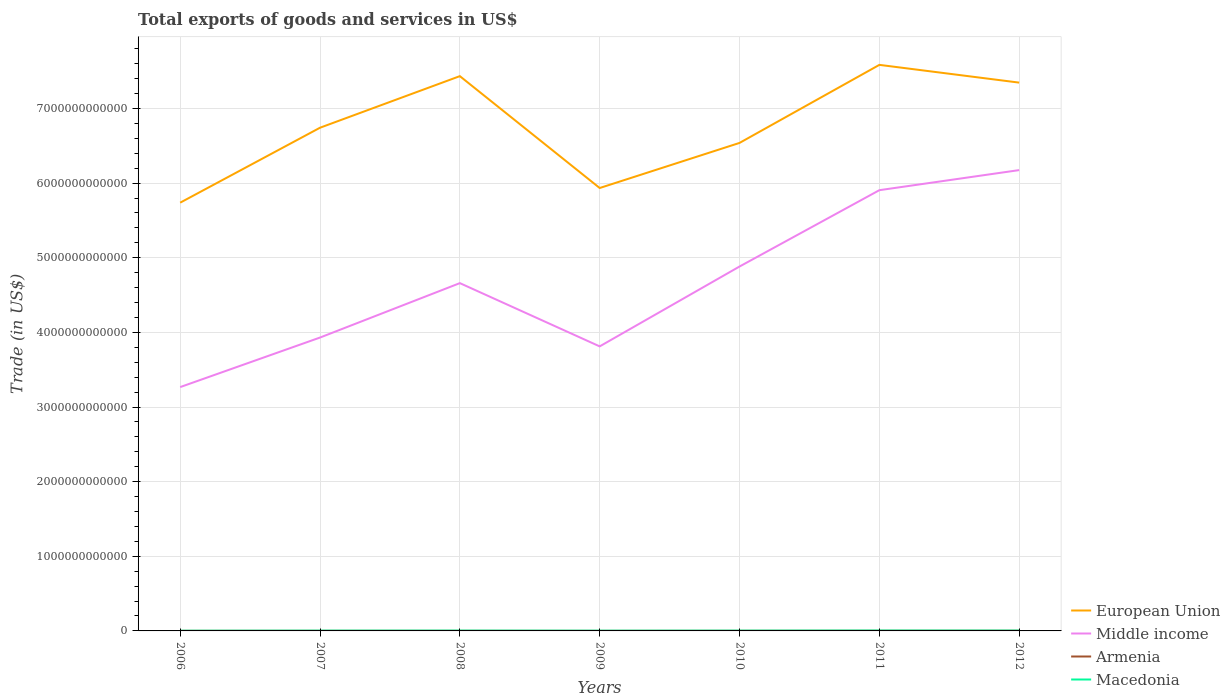How many different coloured lines are there?
Provide a short and direct response. 4. Does the line corresponding to European Union intersect with the line corresponding to Armenia?
Your answer should be compact. No. Across all years, what is the maximum total exports of goods and services in Middle income?
Give a very brief answer. 3.27e+12. In which year was the total exports of goods and services in Armenia maximum?
Provide a short and direct response. 2009. What is the total total exports of goods and services in Macedonia in the graph?
Offer a terse response. -1.34e+09. What is the difference between the highest and the second highest total exports of goods and services in Macedonia?
Make the answer very short. 2.35e+09. What is the difference between the highest and the lowest total exports of goods and services in European Union?
Your answer should be compact. 3. How many years are there in the graph?
Provide a succinct answer. 7. What is the difference between two consecutive major ticks on the Y-axis?
Make the answer very short. 1.00e+12. Are the values on the major ticks of Y-axis written in scientific E-notation?
Offer a very short reply. No. Does the graph contain any zero values?
Your answer should be very brief. No. Does the graph contain grids?
Ensure brevity in your answer.  Yes. Where does the legend appear in the graph?
Your answer should be compact. Bottom right. What is the title of the graph?
Provide a succinct answer. Total exports of goods and services in US$. Does "Dominica" appear as one of the legend labels in the graph?
Ensure brevity in your answer.  No. What is the label or title of the Y-axis?
Ensure brevity in your answer.  Trade (in US$). What is the Trade (in US$) in European Union in 2006?
Your answer should be compact. 5.74e+12. What is the Trade (in US$) of Middle income in 2006?
Give a very brief answer. 3.27e+12. What is the Trade (in US$) of Armenia in 2006?
Provide a succinct answer. 1.49e+09. What is the Trade (in US$) in Macedonia in 2006?
Make the answer very short. 2.59e+09. What is the Trade (in US$) in European Union in 2007?
Give a very brief answer. 6.74e+12. What is the Trade (in US$) in Middle income in 2007?
Offer a terse response. 3.93e+12. What is the Trade (in US$) in Armenia in 2007?
Your answer should be compact. 1.77e+09. What is the Trade (in US$) in Macedonia in 2007?
Offer a very short reply. 3.68e+09. What is the Trade (in US$) in European Union in 2008?
Provide a succinct answer. 7.43e+12. What is the Trade (in US$) of Middle income in 2008?
Give a very brief answer. 4.66e+12. What is the Trade (in US$) of Armenia in 2008?
Give a very brief answer. 1.75e+09. What is the Trade (in US$) of Macedonia in 2008?
Give a very brief answer. 4.28e+09. What is the Trade (in US$) in European Union in 2009?
Ensure brevity in your answer.  5.93e+12. What is the Trade (in US$) in Middle income in 2009?
Make the answer very short. 3.81e+12. What is the Trade (in US$) in Armenia in 2009?
Make the answer very short. 1.34e+09. What is the Trade (in US$) in Macedonia in 2009?
Give a very brief answer. 3.08e+09. What is the Trade (in US$) in European Union in 2010?
Offer a very short reply. 6.54e+12. What is the Trade (in US$) of Middle income in 2010?
Provide a succinct answer. 4.88e+12. What is the Trade (in US$) in Armenia in 2010?
Provide a succinct answer. 1.93e+09. What is the Trade (in US$) of Macedonia in 2010?
Offer a terse response. 3.74e+09. What is the Trade (in US$) in European Union in 2011?
Give a very brief answer. 7.58e+12. What is the Trade (in US$) of Middle income in 2011?
Offer a very short reply. 5.91e+12. What is the Trade (in US$) in Armenia in 2011?
Offer a very short reply. 2.41e+09. What is the Trade (in US$) of Macedonia in 2011?
Give a very brief answer. 4.95e+09. What is the Trade (in US$) in European Union in 2012?
Offer a terse response. 7.35e+12. What is the Trade (in US$) in Middle income in 2012?
Provide a short and direct response. 6.17e+12. What is the Trade (in US$) in Armenia in 2012?
Keep it short and to the point. 2.93e+09. What is the Trade (in US$) of Macedonia in 2012?
Provide a short and direct response. 4.42e+09. Across all years, what is the maximum Trade (in US$) of European Union?
Keep it short and to the point. 7.58e+12. Across all years, what is the maximum Trade (in US$) of Middle income?
Offer a terse response. 6.17e+12. Across all years, what is the maximum Trade (in US$) in Armenia?
Give a very brief answer. 2.93e+09. Across all years, what is the maximum Trade (in US$) of Macedonia?
Provide a short and direct response. 4.95e+09. Across all years, what is the minimum Trade (in US$) of European Union?
Offer a very short reply. 5.74e+12. Across all years, what is the minimum Trade (in US$) in Middle income?
Ensure brevity in your answer.  3.27e+12. Across all years, what is the minimum Trade (in US$) in Armenia?
Keep it short and to the point. 1.34e+09. Across all years, what is the minimum Trade (in US$) of Macedonia?
Offer a terse response. 2.59e+09. What is the total Trade (in US$) of European Union in the graph?
Ensure brevity in your answer.  4.73e+13. What is the total Trade (in US$) in Middle income in the graph?
Provide a short and direct response. 3.26e+13. What is the total Trade (in US$) in Armenia in the graph?
Make the answer very short. 1.36e+1. What is the total Trade (in US$) of Macedonia in the graph?
Your response must be concise. 2.67e+1. What is the difference between the Trade (in US$) of European Union in 2006 and that in 2007?
Provide a short and direct response. -1.00e+12. What is the difference between the Trade (in US$) of Middle income in 2006 and that in 2007?
Offer a very short reply. -6.64e+11. What is the difference between the Trade (in US$) of Armenia in 2006 and that in 2007?
Your answer should be very brief. -2.75e+08. What is the difference between the Trade (in US$) in Macedonia in 2006 and that in 2007?
Provide a succinct answer. -1.08e+09. What is the difference between the Trade (in US$) in European Union in 2006 and that in 2008?
Provide a succinct answer. -1.70e+12. What is the difference between the Trade (in US$) of Middle income in 2006 and that in 2008?
Give a very brief answer. -1.39e+12. What is the difference between the Trade (in US$) of Armenia in 2006 and that in 2008?
Provide a short and direct response. -2.63e+08. What is the difference between the Trade (in US$) in Macedonia in 2006 and that in 2008?
Provide a succinct answer. -1.69e+09. What is the difference between the Trade (in US$) in European Union in 2006 and that in 2009?
Offer a terse response. -1.96e+11. What is the difference between the Trade (in US$) of Middle income in 2006 and that in 2009?
Provide a succinct answer. -5.45e+11. What is the difference between the Trade (in US$) in Armenia in 2006 and that in 2009?
Your response must be concise. 1.53e+08. What is the difference between the Trade (in US$) in Macedonia in 2006 and that in 2009?
Give a very brief answer. -4.91e+08. What is the difference between the Trade (in US$) of European Union in 2006 and that in 2010?
Keep it short and to the point. -8.01e+11. What is the difference between the Trade (in US$) in Middle income in 2006 and that in 2010?
Provide a short and direct response. -1.62e+12. What is the difference between the Trade (in US$) of Armenia in 2006 and that in 2010?
Your answer should be very brief. -4.38e+08. What is the difference between the Trade (in US$) of Macedonia in 2006 and that in 2010?
Ensure brevity in your answer.  -1.15e+09. What is the difference between the Trade (in US$) of European Union in 2006 and that in 2011?
Your response must be concise. -1.85e+12. What is the difference between the Trade (in US$) in Middle income in 2006 and that in 2011?
Ensure brevity in your answer.  -2.64e+12. What is the difference between the Trade (in US$) in Armenia in 2006 and that in 2011?
Offer a terse response. -9.18e+08. What is the difference between the Trade (in US$) of Macedonia in 2006 and that in 2011?
Ensure brevity in your answer.  -2.35e+09. What is the difference between the Trade (in US$) of European Union in 2006 and that in 2012?
Your answer should be compact. -1.61e+12. What is the difference between the Trade (in US$) in Middle income in 2006 and that in 2012?
Give a very brief answer. -2.91e+12. What is the difference between the Trade (in US$) of Armenia in 2006 and that in 2012?
Keep it short and to the point. -1.44e+09. What is the difference between the Trade (in US$) in Macedonia in 2006 and that in 2012?
Give a very brief answer. -1.83e+09. What is the difference between the Trade (in US$) in European Union in 2007 and that in 2008?
Give a very brief answer. -6.91e+11. What is the difference between the Trade (in US$) in Middle income in 2007 and that in 2008?
Ensure brevity in your answer.  -7.29e+11. What is the difference between the Trade (in US$) in Armenia in 2007 and that in 2008?
Provide a succinct answer. 1.15e+07. What is the difference between the Trade (in US$) in Macedonia in 2007 and that in 2008?
Make the answer very short. -6.06e+08. What is the difference between the Trade (in US$) in European Union in 2007 and that in 2009?
Provide a succinct answer. 8.08e+11. What is the difference between the Trade (in US$) of Middle income in 2007 and that in 2009?
Offer a very short reply. 1.18e+11. What is the difference between the Trade (in US$) of Armenia in 2007 and that in 2009?
Keep it short and to the point. 4.28e+08. What is the difference between the Trade (in US$) of Macedonia in 2007 and that in 2009?
Offer a terse response. 5.94e+08. What is the difference between the Trade (in US$) of European Union in 2007 and that in 2010?
Keep it short and to the point. 2.04e+11. What is the difference between the Trade (in US$) of Middle income in 2007 and that in 2010?
Your answer should be very brief. -9.52e+11. What is the difference between the Trade (in US$) of Armenia in 2007 and that in 2010?
Provide a short and direct response. -1.63e+08. What is the difference between the Trade (in US$) in Macedonia in 2007 and that in 2010?
Your answer should be compact. -6.53e+07. What is the difference between the Trade (in US$) in European Union in 2007 and that in 2011?
Your response must be concise. -8.42e+11. What is the difference between the Trade (in US$) of Middle income in 2007 and that in 2011?
Offer a very short reply. -1.97e+12. What is the difference between the Trade (in US$) of Armenia in 2007 and that in 2011?
Ensure brevity in your answer.  -6.43e+08. What is the difference between the Trade (in US$) of Macedonia in 2007 and that in 2011?
Provide a succinct answer. -1.27e+09. What is the difference between the Trade (in US$) in European Union in 2007 and that in 2012?
Make the answer very short. -6.04e+11. What is the difference between the Trade (in US$) of Middle income in 2007 and that in 2012?
Give a very brief answer. -2.24e+12. What is the difference between the Trade (in US$) of Armenia in 2007 and that in 2012?
Your answer should be compact. -1.16e+09. What is the difference between the Trade (in US$) of Macedonia in 2007 and that in 2012?
Your response must be concise. -7.44e+08. What is the difference between the Trade (in US$) in European Union in 2008 and that in 2009?
Make the answer very short. 1.50e+12. What is the difference between the Trade (in US$) in Middle income in 2008 and that in 2009?
Your answer should be compact. 8.48e+11. What is the difference between the Trade (in US$) in Armenia in 2008 and that in 2009?
Make the answer very short. 4.17e+08. What is the difference between the Trade (in US$) in Macedonia in 2008 and that in 2009?
Provide a succinct answer. 1.20e+09. What is the difference between the Trade (in US$) in European Union in 2008 and that in 2010?
Ensure brevity in your answer.  8.95e+11. What is the difference between the Trade (in US$) of Middle income in 2008 and that in 2010?
Your response must be concise. -2.22e+11. What is the difference between the Trade (in US$) in Armenia in 2008 and that in 2010?
Make the answer very short. -1.74e+08. What is the difference between the Trade (in US$) of Macedonia in 2008 and that in 2010?
Offer a terse response. 5.40e+08. What is the difference between the Trade (in US$) of European Union in 2008 and that in 2011?
Keep it short and to the point. -1.51e+11. What is the difference between the Trade (in US$) in Middle income in 2008 and that in 2011?
Provide a succinct answer. -1.25e+12. What is the difference between the Trade (in US$) of Armenia in 2008 and that in 2011?
Give a very brief answer. -6.55e+08. What is the difference between the Trade (in US$) in Macedonia in 2008 and that in 2011?
Provide a succinct answer. -6.62e+08. What is the difference between the Trade (in US$) of European Union in 2008 and that in 2012?
Make the answer very short. 8.66e+1. What is the difference between the Trade (in US$) in Middle income in 2008 and that in 2012?
Offer a terse response. -1.51e+12. What is the difference between the Trade (in US$) of Armenia in 2008 and that in 2012?
Make the answer very short. -1.17e+09. What is the difference between the Trade (in US$) in Macedonia in 2008 and that in 2012?
Make the answer very short. -1.39e+08. What is the difference between the Trade (in US$) of European Union in 2009 and that in 2010?
Make the answer very short. -6.04e+11. What is the difference between the Trade (in US$) of Middle income in 2009 and that in 2010?
Your answer should be compact. -1.07e+12. What is the difference between the Trade (in US$) of Armenia in 2009 and that in 2010?
Offer a very short reply. -5.91e+08. What is the difference between the Trade (in US$) in Macedonia in 2009 and that in 2010?
Your response must be concise. -6.59e+08. What is the difference between the Trade (in US$) in European Union in 2009 and that in 2011?
Provide a succinct answer. -1.65e+12. What is the difference between the Trade (in US$) in Middle income in 2009 and that in 2011?
Provide a short and direct response. -2.09e+12. What is the difference between the Trade (in US$) in Armenia in 2009 and that in 2011?
Offer a terse response. -1.07e+09. What is the difference between the Trade (in US$) of Macedonia in 2009 and that in 2011?
Your response must be concise. -1.86e+09. What is the difference between the Trade (in US$) in European Union in 2009 and that in 2012?
Your answer should be compact. -1.41e+12. What is the difference between the Trade (in US$) in Middle income in 2009 and that in 2012?
Your answer should be very brief. -2.36e+12. What is the difference between the Trade (in US$) of Armenia in 2009 and that in 2012?
Provide a succinct answer. -1.59e+09. What is the difference between the Trade (in US$) in Macedonia in 2009 and that in 2012?
Make the answer very short. -1.34e+09. What is the difference between the Trade (in US$) in European Union in 2010 and that in 2011?
Make the answer very short. -1.05e+12. What is the difference between the Trade (in US$) in Middle income in 2010 and that in 2011?
Make the answer very short. -1.02e+12. What is the difference between the Trade (in US$) in Armenia in 2010 and that in 2011?
Give a very brief answer. -4.81e+08. What is the difference between the Trade (in US$) in Macedonia in 2010 and that in 2011?
Keep it short and to the point. -1.20e+09. What is the difference between the Trade (in US$) of European Union in 2010 and that in 2012?
Your answer should be very brief. -8.08e+11. What is the difference between the Trade (in US$) of Middle income in 2010 and that in 2012?
Ensure brevity in your answer.  -1.29e+12. What is the difference between the Trade (in US$) in Armenia in 2010 and that in 2012?
Your answer should be compact. -9.98e+08. What is the difference between the Trade (in US$) in Macedonia in 2010 and that in 2012?
Make the answer very short. -6.79e+08. What is the difference between the Trade (in US$) in European Union in 2011 and that in 2012?
Keep it short and to the point. 2.38e+11. What is the difference between the Trade (in US$) in Middle income in 2011 and that in 2012?
Offer a terse response. -2.69e+11. What is the difference between the Trade (in US$) of Armenia in 2011 and that in 2012?
Your response must be concise. -5.18e+08. What is the difference between the Trade (in US$) of Macedonia in 2011 and that in 2012?
Ensure brevity in your answer.  5.24e+08. What is the difference between the Trade (in US$) of European Union in 2006 and the Trade (in US$) of Middle income in 2007?
Your answer should be compact. 1.81e+12. What is the difference between the Trade (in US$) in European Union in 2006 and the Trade (in US$) in Armenia in 2007?
Provide a succinct answer. 5.74e+12. What is the difference between the Trade (in US$) in European Union in 2006 and the Trade (in US$) in Macedonia in 2007?
Your answer should be very brief. 5.73e+12. What is the difference between the Trade (in US$) in Middle income in 2006 and the Trade (in US$) in Armenia in 2007?
Provide a succinct answer. 3.27e+12. What is the difference between the Trade (in US$) in Middle income in 2006 and the Trade (in US$) in Macedonia in 2007?
Your answer should be very brief. 3.26e+12. What is the difference between the Trade (in US$) in Armenia in 2006 and the Trade (in US$) in Macedonia in 2007?
Make the answer very short. -2.19e+09. What is the difference between the Trade (in US$) in European Union in 2006 and the Trade (in US$) in Middle income in 2008?
Offer a very short reply. 1.08e+12. What is the difference between the Trade (in US$) in European Union in 2006 and the Trade (in US$) in Armenia in 2008?
Your answer should be very brief. 5.74e+12. What is the difference between the Trade (in US$) in European Union in 2006 and the Trade (in US$) in Macedonia in 2008?
Keep it short and to the point. 5.73e+12. What is the difference between the Trade (in US$) of Middle income in 2006 and the Trade (in US$) of Armenia in 2008?
Your answer should be very brief. 3.27e+12. What is the difference between the Trade (in US$) in Middle income in 2006 and the Trade (in US$) in Macedonia in 2008?
Your response must be concise. 3.26e+12. What is the difference between the Trade (in US$) in Armenia in 2006 and the Trade (in US$) in Macedonia in 2008?
Make the answer very short. -2.79e+09. What is the difference between the Trade (in US$) of European Union in 2006 and the Trade (in US$) of Middle income in 2009?
Offer a very short reply. 1.93e+12. What is the difference between the Trade (in US$) of European Union in 2006 and the Trade (in US$) of Armenia in 2009?
Your answer should be compact. 5.74e+12. What is the difference between the Trade (in US$) in European Union in 2006 and the Trade (in US$) in Macedonia in 2009?
Your answer should be very brief. 5.74e+12. What is the difference between the Trade (in US$) in Middle income in 2006 and the Trade (in US$) in Armenia in 2009?
Your response must be concise. 3.27e+12. What is the difference between the Trade (in US$) in Middle income in 2006 and the Trade (in US$) in Macedonia in 2009?
Provide a succinct answer. 3.26e+12. What is the difference between the Trade (in US$) in Armenia in 2006 and the Trade (in US$) in Macedonia in 2009?
Offer a terse response. -1.59e+09. What is the difference between the Trade (in US$) of European Union in 2006 and the Trade (in US$) of Middle income in 2010?
Your response must be concise. 8.56e+11. What is the difference between the Trade (in US$) of European Union in 2006 and the Trade (in US$) of Armenia in 2010?
Ensure brevity in your answer.  5.74e+12. What is the difference between the Trade (in US$) in European Union in 2006 and the Trade (in US$) in Macedonia in 2010?
Your answer should be compact. 5.73e+12. What is the difference between the Trade (in US$) of Middle income in 2006 and the Trade (in US$) of Armenia in 2010?
Make the answer very short. 3.27e+12. What is the difference between the Trade (in US$) of Middle income in 2006 and the Trade (in US$) of Macedonia in 2010?
Keep it short and to the point. 3.26e+12. What is the difference between the Trade (in US$) in Armenia in 2006 and the Trade (in US$) in Macedonia in 2010?
Make the answer very short. -2.25e+09. What is the difference between the Trade (in US$) in European Union in 2006 and the Trade (in US$) in Middle income in 2011?
Your answer should be compact. -1.67e+11. What is the difference between the Trade (in US$) in European Union in 2006 and the Trade (in US$) in Armenia in 2011?
Provide a succinct answer. 5.74e+12. What is the difference between the Trade (in US$) in European Union in 2006 and the Trade (in US$) in Macedonia in 2011?
Ensure brevity in your answer.  5.73e+12. What is the difference between the Trade (in US$) in Middle income in 2006 and the Trade (in US$) in Armenia in 2011?
Your answer should be compact. 3.26e+12. What is the difference between the Trade (in US$) in Middle income in 2006 and the Trade (in US$) in Macedonia in 2011?
Provide a succinct answer. 3.26e+12. What is the difference between the Trade (in US$) of Armenia in 2006 and the Trade (in US$) of Macedonia in 2011?
Give a very brief answer. -3.45e+09. What is the difference between the Trade (in US$) in European Union in 2006 and the Trade (in US$) in Middle income in 2012?
Ensure brevity in your answer.  -4.37e+11. What is the difference between the Trade (in US$) of European Union in 2006 and the Trade (in US$) of Armenia in 2012?
Your answer should be very brief. 5.74e+12. What is the difference between the Trade (in US$) in European Union in 2006 and the Trade (in US$) in Macedonia in 2012?
Make the answer very short. 5.73e+12. What is the difference between the Trade (in US$) in Middle income in 2006 and the Trade (in US$) in Armenia in 2012?
Offer a very short reply. 3.26e+12. What is the difference between the Trade (in US$) of Middle income in 2006 and the Trade (in US$) of Macedonia in 2012?
Ensure brevity in your answer.  3.26e+12. What is the difference between the Trade (in US$) in Armenia in 2006 and the Trade (in US$) in Macedonia in 2012?
Your response must be concise. -2.93e+09. What is the difference between the Trade (in US$) of European Union in 2007 and the Trade (in US$) of Middle income in 2008?
Provide a succinct answer. 2.08e+12. What is the difference between the Trade (in US$) in European Union in 2007 and the Trade (in US$) in Armenia in 2008?
Your answer should be compact. 6.74e+12. What is the difference between the Trade (in US$) of European Union in 2007 and the Trade (in US$) of Macedonia in 2008?
Your response must be concise. 6.74e+12. What is the difference between the Trade (in US$) of Middle income in 2007 and the Trade (in US$) of Armenia in 2008?
Keep it short and to the point. 3.93e+12. What is the difference between the Trade (in US$) of Middle income in 2007 and the Trade (in US$) of Macedonia in 2008?
Offer a very short reply. 3.93e+12. What is the difference between the Trade (in US$) in Armenia in 2007 and the Trade (in US$) in Macedonia in 2008?
Your answer should be compact. -2.52e+09. What is the difference between the Trade (in US$) in European Union in 2007 and the Trade (in US$) in Middle income in 2009?
Keep it short and to the point. 2.93e+12. What is the difference between the Trade (in US$) of European Union in 2007 and the Trade (in US$) of Armenia in 2009?
Your answer should be compact. 6.74e+12. What is the difference between the Trade (in US$) of European Union in 2007 and the Trade (in US$) of Macedonia in 2009?
Provide a succinct answer. 6.74e+12. What is the difference between the Trade (in US$) in Middle income in 2007 and the Trade (in US$) in Armenia in 2009?
Your answer should be very brief. 3.93e+12. What is the difference between the Trade (in US$) of Middle income in 2007 and the Trade (in US$) of Macedonia in 2009?
Make the answer very short. 3.93e+12. What is the difference between the Trade (in US$) in Armenia in 2007 and the Trade (in US$) in Macedonia in 2009?
Your response must be concise. -1.32e+09. What is the difference between the Trade (in US$) of European Union in 2007 and the Trade (in US$) of Middle income in 2010?
Offer a very short reply. 1.86e+12. What is the difference between the Trade (in US$) in European Union in 2007 and the Trade (in US$) in Armenia in 2010?
Your response must be concise. 6.74e+12. What is the difference between the Trade (in US$) in European Union in 2007 and the Trade (in US$) in Macedonia in 2010?
Make the answer very short. 6.74e+12. What is the difference between the Trade (in US$) of Middle income in 2007 and the Trade (in US$) of Armenia in 2010?
Offer a terse response. 3.93e+12. What is the difference between the Trade (in US$) of Middle income in 2007 and the Trade (in US$) of Macedonia in 2010?
Ensure brevity in your answer.  3.93e+12. What is the difference between the Trade (in US$) in Armenia in 2007 and the Trade (in US$) in Macedonia in 2010?
Provide a succinct answer. -1.98e+09. What is the difference between the Trade (in US$) in European Union in 2007 and the Trade (in US$) in Middle income in 2011?
Ensure brevity in your answer.  8.37e+11. What is the difference between the Trade (in US$) of European Union in 2007 and the Trade (in US$) of Armenia in 2011?
Make the answer very short. 6.74e+12. What is the difference between the Trade (in US$) in European Union in 2007 and the Trade (in US$) in Macedonia in 2011?
Make the answer very short. 6.74e+12. What is the difference between the Trade (in US$) in Middle income in 2007 and the Trade (in US$) in Armenia in 2011?
Keep it short and to the point. 3.93e+12. What is the difference between the Trade (in US$) of Middle income in 2007 and the Trade (in US$) of Macedonia in 2011?
Give a very brief answer. 3.93e+12. What is the difference between the Trade (in US$) of Armenia in 2007 and the Trade (in US$) of Macedonia in 2011?
Your answer should be compact. -3.18e+09. What is the difference between the Trade (in US$) of European Union in 2007 and the Trade (in US$) of Middle income in 2012?
Provide a short and direct response. 5.68e+11. What is the difference between the Trade (in US$) in European Union in 2007 and the Trade (in US$) in Armenia in 2012?
Provide a succinct answer. 6.74e+12. What is the difference between the Trade (in US$) in European Union in 2007 and the Trade (in US$) in Macedonia in 2012?
Ensure brevity in your answer.  6.74e+12. What is the difference between the Trade (in US$) in Middle income in 2007 and the Trade (in US$) in Armenia in 2012?
Provide a succinct answer. 3.93e+12. What is the difference between the Trade (in US$) in Middle income in 2007 and the Trade (in US$) in Macedonia in 2012?
Keep it short and to the point. 3.93e+12. What is the difference between the Trade (in US$) of Armenia in 2007 and the Trade (in US$) of Macedonia in 2012?
Give a very brief answer. -2.66e+09. What is the difference between the Trade (in US$) in European Union in 2008 and the Trade (in US$) in Middle income in 2009?
Offer a terse response. 3.62e+12. What is the difference between the Trade (in US$) in European Union in 2008 and the Trade (in US$) in Armenia in 2009?
Give a very brief answer. 7.43e+12. What is the difference between the Trade (in US$) in European Union in 2008 and the Trade (in US$) in Macedonia in 2009?
Your answer should be compact. 7.43e+12. What is the difference between the Trade (in US$) in Middle income in 2008 and the Trade (in US$) in Armenia in 2009?
Give a very brief answer. 4.66e+12. What is the difference between the Trade (in US$) of Middle income in 2008 and the Trade (in US$) of Macedonia in 2009?
Ensure brevity in your answer.  4.66e+12. What is the difference between the Trade (in US$) in Armenia in 2008 and the Trade (in US$) in Macedonia in 2009?
Provide a short and direct response. -1.33e+09. What is the difference between the Trade (in US$) in European Union in 2008 and the Trade (in US$) in Middle income in 2010?
Provide a short and direct response. 2.55e+12. What is the difference between the Trade (in US$) of European Union in 2008 and the Trade (in US$) of Armenia in 2010?
Your answer should be compact. 7.43e+12. What is the difference between the Trade (in US$) of European Union in 2008 and the Trade (in US$) of Macedonia in 2010?
Keep it short and to the point. 7.43e+12. What is the difference between the Trade (in US$) in Middle income in 2008 and the Trade (in US$) in Armenia in 2010?
Ensure brevity in your answer.  4.66e+12. What is the difference between the Trade (in US$) in Middle income in 2008 and the Trade (in US$) in Macedonia in 2010?
Give a very brief answer. 4.66e+12. What is the difference between the Trade (in US$) in Armenia in 2008 and the Trade (in US$) in Macedonia in 2010?
Keep it short and to the point. -1.99e+09. What is the difference between the Trade (in US$) in European Union in 2008 and the Trade (in US$) in Middle income in 2011?
Your response must be concise. 1.53e+12. What is the difference between the Trade (in US$) in European Union in 2008 and the Trade (in US$) in Armenia in 2011?
Your answer should be compact. 7.43e+12. What is the difference between the Trade (in US$) in European Union in 2008 and the Trade (in US$) in Macedonia in 2011?
Provide a succinct answer. 7.43e+12. What is the difference between the Trade (in US$) in Middle income in 2008 and the Trade (in US$) in Armenia in 2011?
Provide a succinct answer. 4.66e+12. What is the difference between the Trade (in US$) of Middle income in 2008 and the Trade (in US$) of Macedonia in 2011?
Give a very brief answer. 4.66e+12. What is the difference between the Trade (in US$) of Armenia in 2008 and the Trade (in US$) of Macedonia in 2011?
Ensure brevity in your answer.  -3.19e+09. What is the difference between the Trade (in US$) in European Union in 2008 and the Trade (in US$) in Middle income in 2012?
Offer a terse response. 1.26e+12. What is the difference between the Trade (in US$) in European Union in 2008 and the Trade (in US$) in Armenia in 2012?
Provide a short and direct response. 7.43e+12. What is the difference between the Trade (in US$) of European Union in 2008 and the Trade (in US$) of Macedonia in 2012?
Keep it short and to the point. 7.43e+12. What is the difference between the Trade (in US$) of Middle income in 2008 and the Trade (in US$) of Armenia in 2012?
Provide a short and direct response. 4.66e+12. What is the difference between the Trade (in US$) of Middle income in 2008 and the Trade (in US$) of Macedonia in 2012?
Your answer should be very brief. 4.66e+12. What is the difference between the Trade (in US$) in Armenia in 2008 and the Trade (in US$) in Macedonia in 2012?
Provide a short and direct response. -2.67e+09. What is the difference between the Trade (in US$) in European Union in 2009 and the Trade (in US$) in Middle income in 2010?
Your answer should be very brief. 1.05e+12. What is the difference between the Trade (in US$) in European Union in 2009 and the Trade (in US$) in Armenia in 2010?
Give a very brief answer. 5.93e+12. What is the difference between the Trade (in US$) in European Union in 2009 and the Trade (in US$) in Macedonia in 2010?
Your answer should be very brief. 5.93e+12. What is the difference between the Trade (in US$) in Middle income in 2009 and the Trade (in US$) in Armenia in 2010?
Provide a succinct answer. 3.81e+12. What is the difference between the Trade (in US$) of Middle income in 2009 and the Trade (in US$) of Macedonia in 2010?
Provide a short and direct response. 3.81e+12. What is the difference between the Trade (in US$) of Armenia in 2009 and the Trade (in US$) of Macedonia in 2010?
Provide a short and direct response. -2.40e+09. What is the difference between the Trade (in US$) of European Union in 2009 and the Trade (in US$) of Middle income in 2011?
Ensure brevity in your answer.  2.90e+1. What is the difference between the Trade (in US$) of European Union in 2009 and the Trade (in US$) of Armenia in 2011?
Ensure brevity in your answer.  5.93e+12. What is the difference between the Trade (in US$) of European Union in 2009 and the Trade (in US$) of Macedonia in 2011?
Offer a terse response. 5.93e+12. What is the difference between the Trade (in US$) in Middle income in 2009 and the Trade (in US$) in Armenia in 2011?
Your answer should be compact. 3.81e+12. What is the difference between the Trade (in US$) of Middle income in 2009 and the Trade (in US$) of Macedonia in 2011?
Make the answer very short. 3.81e+12. What is the difference between the Trade (in US$) in Armenia in 2009 and the Trade (in US$) in Macedonia in 2011?
Your response must be concise. -3.61e+09. What is the difference between the Trade (in US$) in European Union in 2009 and the Trade (in US$) in Middle income in 2012?
Your answer should be compact. -2.40e+11. What is the difference between the Trade (in US$) of European Union in 2009 and the Trade (in US$) of Armenia in 2012?
Your answer should be compact. 5.93e+12. What is the difference between the Trade (in US$) of European Union in 2009 and the Trade (in US$) of Macedonia in 2012?
Ensure brevity in your answer.  5.93e+12. What is the difference between the Trade (in US$) in Middle income in 2009 and the Trade (in US$) in Armenia in 2012?
Your answer should be compact. 3.81e+12. What is the difference between the Trade (in US$) in Middle income in 2009 and the Trade (in US$) in Macedonia in 2012?
Offer a very short reply. 3.81e+12. What is the difference between the Trade (in US$) in Armenia in 2009 and the Trade (in US$) in Macedonia in 2012?
Keep it short and to the point. -3.08e+09. What is the difference between the Trade (in US$) in European Union in 2010 and the Trade (in US$) in Middle income in 2011?
Ensure brevity in your answer.  6.33e+11. What is the difference between the Trade (in US$) in European Union in 2010 and the Trade (in US$) in Armenia in 2011?
Offer a terse response. 6.54e+12. What is the difference between the Trade (in US$) of European Union in 2010 and the Trade (in US$) of Macedonia in 2011?
Ensure brevity in your answer.  6.53e+12. What is the difference between the Trade (in US$) in Middle income in 2010 and the Trade (in US$) in Armenia in 2011?
Make the answer very short. 4.88e+12. What is the difference between the Trade (in US$) of Middle income in 2010 and the Trade (in US$) of Macedonia in 2011?
Provide a succinct answer. 4.88e+12. What is the difference between the Trade (in US$) in Armenia in 2010 and the Trade (in US$) in Macedonia in 2011?
Provide a short and direct response. -3.02e+09. What is the difference between the Trade (in US$) of European Union in 2010 and the Trade (in US$) of Middle income in 2012?
Your answer should be compact. 3.64e+11. What is the difference between the Trade (in US$) of European Union in 2010 and the Trade (in US$) of Armenia in 2012?
Ensure brevity in your answer.  6.54e+12. What is the difference between the Trade (in US$) of European Union in 2010 and the Trade (in US$) of Macedonia in 2012?
Your answer should be compact. 6.53e+12. What is the difference between the Trade (in US$) of Middle income in 2010 and the Trade (in US$) of Armenia in 2012?
Provide a succinct answer. 4.88e+12. What is the difference between the Trade (in US$) in Middle income in 2010 and the Trade (in US$) in Macedonia in 2012?
Provide a succinct answer. 4.88e+12. What is the difference between the Trade (in US$) in Armenia in 2010 and the Trade (in US$) in Macedonia in 2012?
Keep it short and to the point. -2.49e+09. What is the difference between the Trade (in US$) in European Union in 2011 and the Trade (in US$) in Middle income in 2012?
Make the answer very short. 1.41e+12. What is the difference between the Trade (in US$) in European Union in 2011 and the Trade (in US$) in Armenia in 2012?
Provide a succinct answer. 7.58e+12. What is the difference between the Trade (in US$) in European Union in 2011 and the Trade (in US$) in Macedonia in 2012?
Keep it short and to the point. 7.58e+12. What is the difference between the Trade (in US$) of Middle income in 2011 and the Trade (in US$) of Armenia in 2012?
Provide a short and direct response. 5.90e+12. What is the difference between the Trade (in US$) in Middle income in 2011 and the Trade (in US$) in Macedonia in 2012?
Provide a short and direct response. 5.90e+12. What is the difference between the Trade (in US$) of Armenia in 2011 and the Trade (in US$) of Macedonia in 2012?
Provide a short and direct response. -2.01e+09. What is the average Trade (in US$) of European Union per year?
Offer a very short reply. 6.76e+12. What is the average Trade (in US$) in Middle income per year?
Provide a short and direct response. 4.66e+12. What is the average Trade (in US$) in Armenia per year?
Your response must be concise. 1.95e+09. What is the average Trade (in US$) in Macedonia per year?
Your answer should be very brief. 3.82e+09. In the year 2006, what is the difference between the Trade (in US$) of European Union and Trade (in US$) of Middle income?
Keep it short and to the point. 2.47e+12. In the year 2006, what is the difference between the Trade (in US$) of European Union and Trade (in US$) of Armenia?
Offer a very short reply. 5.74e+12. In the year 2006, what is the difference between the Trade (in US$) in European Union and Trade (in US$) in Macedonia?
Provide a short and direct response. 5.74e+12. In the year 2006, what is the difference between the Trade (in US$) in Middle income and Trade (in US$) in Armenia?
Ensure brevity in your answer.  3.27e+12. In the year 2006, what is the difference between the Trade (in US$) in Middle income and Trade (in US$) in Macedonia?
Your answer should be compact. 3.26e+12. In the year 2006, what is the difference between the Trade (in US$) in Armenia and Trade (in US$) in Macedonia?
Give a very brief answer. -1.10e+09. In the year 2007, what is the difference between the Trade (in US$) of European Union and Trade (in US$) of Middle income?
Provide a short and direct response. 2.81e+12. In the year 2007, what is the difference between the Trade (in US$) of European Union and Trade (in US$) of Armenia?
Your answer should be very brief. 6.74e+12. In the year 2007, what is the difference between the Trade (in US$) of European Union and Trade (in US$) of Macedonia?
Provide a succinct answer. 6.74e+12. In the year 2007, what is the difference between the Trade (in US$) in Middle income and Trade (in US$) in Armenia?
Your answer should be compact. 3.93e+12. In the year 2007, what is the difference between the Trade (in US$) of Middle income and Trade (in US$) of Macedonia?
Your answer should be very brief. 3.93e+12. In the year 2007, what is the difference between the Trade (in US$) of Armenia and Trade (in US$) of Macedonia?
Offer a very short reply. -1.91e+09. In the year 2008, what is the difference between the Trade (in US$) in European Union and Trade (in US$) in Middle income?
Your answer should be compact. 2.77e+12. In the year 2008, what is the difference between the Trade (in US$) in European Union and Trade (in US$) in Armenia?
Ensure brevity in your answer.  7.43e+12. In the year 2008, what is the difference between the Trade (in US$) of European Union and Trade (in US$) of Macedonia?
Give a very brief answer. 7.43e+12. In the year 2008, what is the difference between the Trade (in US$) of Middle income and Trade (in US$) of Armenia?
Offer a very short reply. 4.66e+12. In the year 2008, what is the difference between the Trade (in US$) of Middle income and Trade (in US$) of Macedonia?
Provide a succinct answer. 4.66e+12. In the year 2008, what is the difference between the Trade (in US$) of Armenia and Trade (in US$) of Macedonia?
Offer a terse response. -2.53e+09. In the year 2009, what is the difference between the Trade (in US$) in European Union and Trade (in US$) in Middle income?
Keep it short and to the point. 2.12e+12. In the year 2009, what is the difference between the Trade (in US$) in European Union and Trade (in US$) in Armenia?
Provide a succinct answer. 5.93e+12. In the year 2009, what is the difference between the Trade (in US$) in European Union and Trade (in US$) in Macedonia?
Your answer should be very brief. 5.93e+12. In the year 2009, what is the difference between the Trade (in US$) of Middle income and Trade (in US$) of Armenia?
Ensure brevity in your answer.  3.81e+12. In the year 2009, what is the difference between the Trade (in US$) in Middle income and Trade (in US$) in Macedonia?
Ensure brevity in your answer.  3.81e+12. In the year 2009, what is the difference between the Trade (in US$) of Armenia and Trade (in US$) of Macedonia?
Offer a very short reply. -1.75e+09. In the year 2010, what is the difference between the Trade (in US$) of European Union and Trade (in US$) of Middle income?
Your response must be concise. 1.66e+12. In the year 2010, what is the difference between the Trade (in US$) of European Union and Trade (in US$) of Armenia?
Ensure brevity in your answer.  6.54e+12. In the year 2010, what is the difference between the Trade (in US$) of European Union and Trade (in US$) of Macedonia?
Provide a succinct answer. 6.54e+12. In the year 2010, what is the difference between the Trade (in US$) in Middle income and Trade (in US$) in Armenia?
Provide a short and direct response. 4.88e+12. In the year 2010, what is the difference between the Trade (in US$) in Middle income and Trade (in US$) in Macedonia?
Give a very brief answer. 4.88e+12. In the year 2010, what is the difference between the Trade (in US$) of Armenia and Trade (in US$) of Macedonia?
Give a very brief answer. -1.81e+09. In the year 2011, what is the difference between the Trade (in US$) in European Union and Trade (in US$) in Middle income?
Provide a short and direct response. 1.68e+12. In the year 2011, what is the difference between the Trade (in US$) of European Union and Trade (in US$) of Armenia?
Ensure brevity in your answer.  7.58e+12. In the year 2011, what is the difference between the Trade (in US$) of European Union and Trade (in US$) of Macedonia?
Keep it short and to the point. 7.58e+12. In the year 2011, what is the difference between the Trade (in US$) of Middle income and Trade (in US$) of Armenia?
Your answer should be very brief. 5.90e+12. In the year 2011, what is the difference between the Trade (in US$) of Middle income and Trade (in US$) of Macedonia?
Offer a very short reply. 5.90e+12. In the year 2011, what is the difference between the Trade (in US$) of Armenia and Trade (in US$) of Macedonia?
Your answer should be compact. -2.54e+09. In the year 2012, what is the difference between the Trade (in US$) in European Union and Trade (in US$) in Middle income?
Your answer should be very brief. 1.17e+12. In the year 2012, what is the difference between the Trade (in US$) in European Union and Trade (in US$) in Armenia?
Ensure brevity in your answer.  7.34e+12. In the year 2012, what is the difference between the Trade (in US$) of European Union and Trade (in US$) of Macedonia?
Provide a succinct answer. 7.34e+12. In the year 2012, what is the difference between the Trade (in US$) in Middle income and Trade (in US$) in Armenia?
Provide a succinct answer. 6.17e+12. In the year 2012, what is the difference between the Trade (in US$) of Middle income and Trade (in US$) of Macedonia?
Your answer should be very brief. 6.17e+12. In the year 2012, what is the difference between the Trade (in US$) in Armenia and Trade (in US$) in Macedonia?
Provide a short and direct response. -1.49e+09. What is the ratio of the Trade (in US$) in European Union in 2006 to that in 2007?
Your response must be concise. 0.85. What is the ratio of the Trade (in US$) of Middle income in 2006 to that in 2007?
Make the answer very short. 0.83. What is the ratio of the Trade (in US$) in Armenia in 2006 to that in 2007?
Offer a terse response. 0.84. What is the ratio of the Trade (in US$) of Macedonia in 2006 to that in 2007?
Give a very brief answer. 0.7. What is the ratio of the Trade (in US$) of European Union in 2006 to that in 2008?
Offer a terse response. 0.77. What is the ratio of the Trade (in US$) in Middle income in 2006 to that in 2008?
Ensure brevity in your answer.  0.7. What is the ratio of the Trade (in US$) of Armenia in 2006 to that in 2008?
Your response must be concise. 0.85. What is the ratio of the Trade (in US$) of Macedonia in 2006 to that in 2008?
Ensure brevity in your answer.  0.61. What is the ratio of the Trade (in US$) in European Union in 2006 to that in 2009?
Your response must be concise. 0.97. What is the ratio of the Trade (in US$) of Middle income in 2006 to that in 2009?
Keep it short and to the point. 0.86. What is the ratio of the Trade (in US$) in Armenia in 2006 to that in 2009?
Keep it short and to the point. 1.11. What is the ratio of the Trade (in US$) of Macedonia in 2006 to that in 2009?
Make the answer very short. 0.84. What is the ratio of the Trade (in US$) in European Union in 2006 to that in 2010?
Make the answer very short. 0.88. What is the ratio of the Trade (in US$) of Middle income in 2006 to that in 2010?
Ensure brevity in your answer.  0.67. What is the ratio of the Trade (in US$) in Armenia in 2006 to that in 2010?
Offer a terse response. 0.77. What is the ratio of the Trade (in US$) in Macedonia in 2006 to that in 2010?
Your answer should be very brief. 0.69. What is the ratio of the Trade (in US$) in European Union in 2006 to that in 2011?
Your response must be concise. 0.76. What is the ratio of the Trade (in US$) of Middle income in 2006 to that in 2011?
Keep it short and to the point. 0.55. What is the ratio of the Trade (in US$) in Armenia in 2006 to that in 2011?
Make the answer very short. 0.62. What is the ratio of the Trade (in US$) in Macedonia in 2006 to that in 2011?
Your answer should be compact. 0.52. What is the ratio of the Trade (in US$) of European Union in 2006 to that in 2012?
Offer a very short reply. 0.78. What is the ratio of the Trade (in US$) of Middle income in 2006 to that in 2012?
Provide a succinct answer. 0.53. What is the ratio of the Trade (in US$) of Armenia in 2006 to that in 2012?
Your answer should be compact. 0.51. What is the ratio of the Trade (in US$) of Macedonia in 2006 to that in 2012?
Provide a succinct answer. 0.59. What is the ratio of the Trade (in US$) of European Union in 2007 to that in 2008?
Provide a short and direct response. 0.91. What is the ratio of the Trade (in US$) in Middle income in 2007 to that in 2008?
Your answer should be compact. 0.84. What is the ratio of the Trade (in US$) of Armenia in 2007 to that in 2008?
Your answer should be very brief. 1.01. What is the ratio of the Trade (in US$) of Macedonia in 2007 to that in 2008?
Keep it short and to the point. 0.86. What is the ratio of the Trade (in US$) in European Union in 2007 to that in 2009?
Keep it short and to the point. 1.14. What is the ratio of the Trade (in US$) in Middle income in 2007 to that in 2009?
Offer a very short reply. 1.03. What is the ratio of the Trade (in US$) of Armenia in 2007 to that in 2009?
Offer a terse response. 1.32. What is the ratio of the Trade (in US$) in Macedonia in 2007 to that in 2009?
Keep it short and to the point. 1.19. What is the ratio of the Trade (in US$) in European Union in 2007 to that in 2010?
Give a very brief answer. 1.03. What is the ratio of the Trade (in US$) in Middle income in 2007 to that in 2010?
Keep it short and to the point. 0.81. What is the ratio of the Trade (in US$) in Armenia in 2007 to that in 2010?
Provide a short and direct response. 0.92. What is the ratio of the Trade (in US$) of Macedonia in 2007 to that in 2010?
Offer a terse response. 0.98. What is the ratio of the Trade (in US$) of European Union in 2007 to that in 2011?
Your response must be concise. 0.89. What is the ratio of the Trade (in US$) of Middle income in 2007 to that in 2011?
Offer a terse response. 0.67. What is the ratio of the Trade (in US$) of Armenia in 2007 to that in 2011?
Make the answer very short. 0.73. What is the ratio of the Trade (in US$) of Macedonia in 2007 to that in 2011?
Provide a short and direct response. 0.74. What is the ratio of the Trade (in US$) in European Union in 2007 to that in 2012?
Your answer should be very brief. 0.92. What is the ratio of the Trade (in US$) of Middle income in 2007 to that in 2012?
Ensure brevity in your answer.  0.64. What is the ratio of the Trade (in US$) of Armenia in 2007 to that in 2012?
Your answer should be compact. 0.6. What is the ratio of the Trade (in US$) of Macedonia in 2007 to that in 2012?
Your answer should be compact. 0.83. What is the ratio of the Trade (in US$) of European Union in 2008 to that in 2009?
Keep it short and to the point. 1.25. What is the ratio of the Trade (in US$) of Middle income in 2008 to that in 2009?
Ensure brevity in your answer.  1.22. What is the ratio of the Trade (in US$) in Armenia in 2008 to that in 2009?
Make the answer very short. 1.31. What is the ratio of the Trade (in US$) of Macedonia in 2008 to that in 2009?
Offer a terse response. 1.39. What is the ratio of the Trade (in US$) of European Union in 2008 to that in 2010?
Make the answer very short. 1.14. What is the ratio of the Trade (in US$) in Middle income in 2008 to that in 2010?
Give a very brief answer. 0.95. What is the ratio of the Trade (in US$) in Armenia in 2008 to that in 2010?
Give a very brief answer. 0.91. What is the ratio of the Trade (in US$) of Macedonia in 2008 to that in 2010?
Make the answer very short. 1.14. What is the ratio of the Trade (in US$) of European Union in 2008 to that in 2011?
Give a very brief answer. 0.98. What is the ratio of the Trade (in US$) in Middle income in 2008 to that in 2011?
Your response must be concise. 0.79. What is the ratio of the Trade (in US$) of Armenia in 2008 to that in 2011?
Offer a terse response. 0.73. What is the ratio of the Trade (in US$) in Macedonia in 2008 to that in 2011?
Give a very brief answer. 0.87. What is the ratio of the Trade (in US$) of European Union in 2008 to that in 2012?
Your answer should be compact. 1.01. What is the ratio of the Trade (in US$) of Middle income in 2008 to that in 2012?
Keep it short and to the point. 0.75. What is the ratio of the Trade (in US$) of Armenia in 2008 to that in 2012?
Keep it short and to the point. 0.6. What is the ratio of the Trade (in US$) in Macedonia in 2008 to that in 2012?
Your response must be concise. 0.97. What is the ratio of the Trade (in US$) of European Union in 2009 to that in 2010?
Offer a very short reply. 0.91. What is the ratio of the Trade (in US$) of Middle income in 2009 to that in 2010?
Offer a terse response. 0.78. What is the ratio of the Trade (in US$) of Armenia in 2009 to that in 2010?
Your answer should be very brief. 0.69. What is the ratio of the Trade (in US$) in Macedonia in 2009 to that in 2010?
Your response must be concise. 0.82. What is the ratio of the Trade (in US$) in European Union in 2009 to that in 2011?
Offer a terse response. 0.78. What is the ratio of the Trade (in US$) in Middle income in 2009 to that in 2011?
Your answer should be very brief. 0.65. What is the ratio of the Trade (in US$) in Armenia in 2009 to that in 2011?
Make the answer very short. 0.56. What is the ratio of the Trade (in US$) in Macedonia in 2009 to that in 2011?
Provide a short and direct response. 0.62. What is the ratio of the Trade (in US$) in European Union in 2009 to that in 2012?
Offer a terse response. 0.81. What is the ratio of the Trade (in US$) of Middle income in 2009 to that in 2012?
Give a very brief answer. 0.62. What is the ratio of the Trade (in US$) in Armenia in 2009 to that in 2012?
Give a very brief answer. 0.46. What is the ratio of the Trade (in US$) in Macedonia in 2009 to that in 2012?
Give a very brief answer. 0.7. What is the ratio of the Trade (in US$) of European Union in 2010 to that in 2011?
Offer a terse response. 0.86. What is the ratio of the Trade (in US$) of Middle income in 2010 to that in 2011?
Keep it short and to the point. 0.83. What is the ratio of the Trade (in US$) of Armenia in 2010 to that in 2011?
Provide a short and direct response. 0.8. What is the ratio of the Trade (in US$) of Macedonia in 2010 to that in 2011?
Offer a terse response. 0.76. What is the ratio of the Trade (in US$) of European Union in 2010 to that in 2012?
Offer a terse response. 0.89. What is the ratio of the Trade (in US$) in Middle income in 2010 to that in 2012?
Make the answer very short. 0.79. What is the ratio of the Trade (in US$) of Armenia in 2010 to that in 2012?
Keep it short and to the point. 0.66. What is the ratio of the Trade (in US$) in Macedonia in 2010 to that in 2012?
Make the answer very short. 0.85. What is the ratio of the Trade (in US$) of European Union in 2011 to that in 2012?
Your answer should be compact. 1.03. What is the ratio of the Trade (in US$) in Middle income in 2011 to that in 2012?
Ensure brevity in your answer.  0.96. What is the ratio of the Trade (in US$) of Armenia in 2011 to that in 2012?
Offer a very short reply. 0.82. What is the ratio of the Trade (in US$) in Macedonia in 2011 to that in 2012?
Keep it short and to the point. 1.12. What is the difference between the highest and the second highest Trade (in US$) of European Union?
Your answer should be compact. 1.51e+11. What is the difference between the highest and the second highest Trade (in US$) in Middle income?
Give a very brief answer. 2.69e+11. What is the difference between the highest and the second highest Trade (in US$) of Armenia?
Make the answer very short. 5.18e+08. What is the difference between the highest and the second highest Trade (in US$) of Macedonia?
Provide a succinct answer. 5.24e+08. What is the difference between the highest and the lowest Trade (in US$) in European Union?
Provide a short and direct response. 1.85e+12. What is the difference between the highest and the lowest Trade (in US$) of Middle income?
Offer a terse response. 2.91e+12. What is the difference between the highest and the lowest Trade (in US$) in Armenia?
Your answer should be very brief. 1.59e+09. What is the difference between the highest and the lowest Trade (in US$) in Macedonia?
Your answer should be very brief. 2.35e+09. 